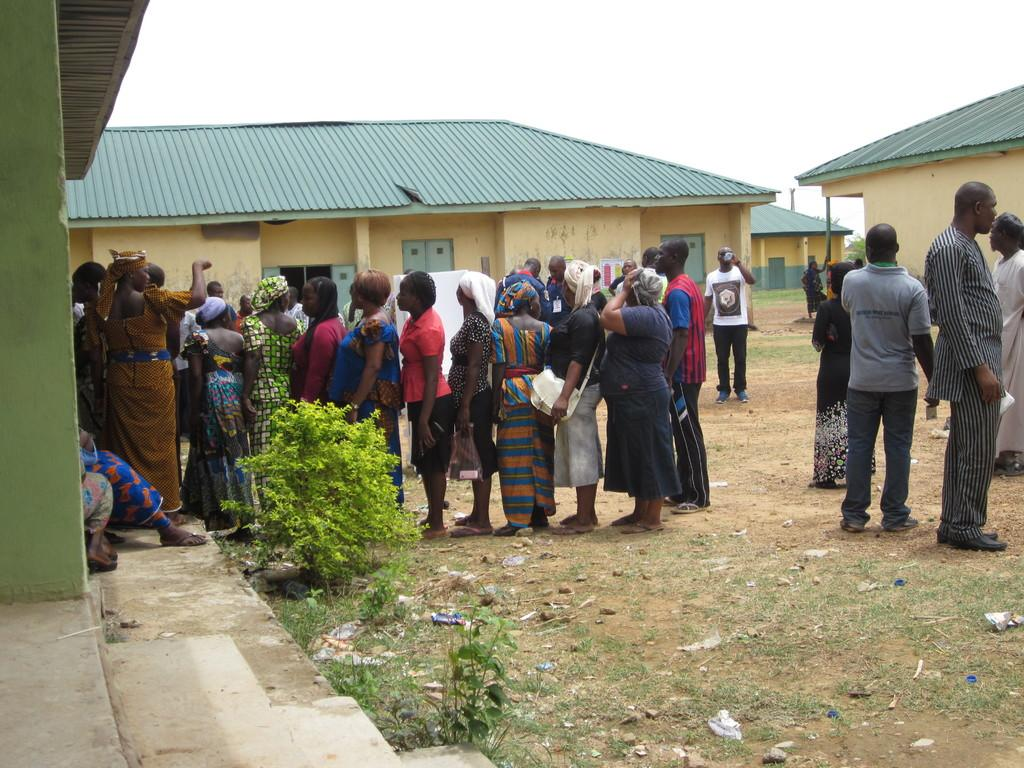How many people are in the image? There is a group of people in the image, but the exact number is not specified. What are the people doing in the image? The people are on the ground, but their specific activity is not mentioned. What can be seen in the background of the image? There are sheds and the sky visible in the background of the image. What type of print can be seen on the people's clothing in the image? There is no information about the people's clothing or any prints on them in the provided facts. 